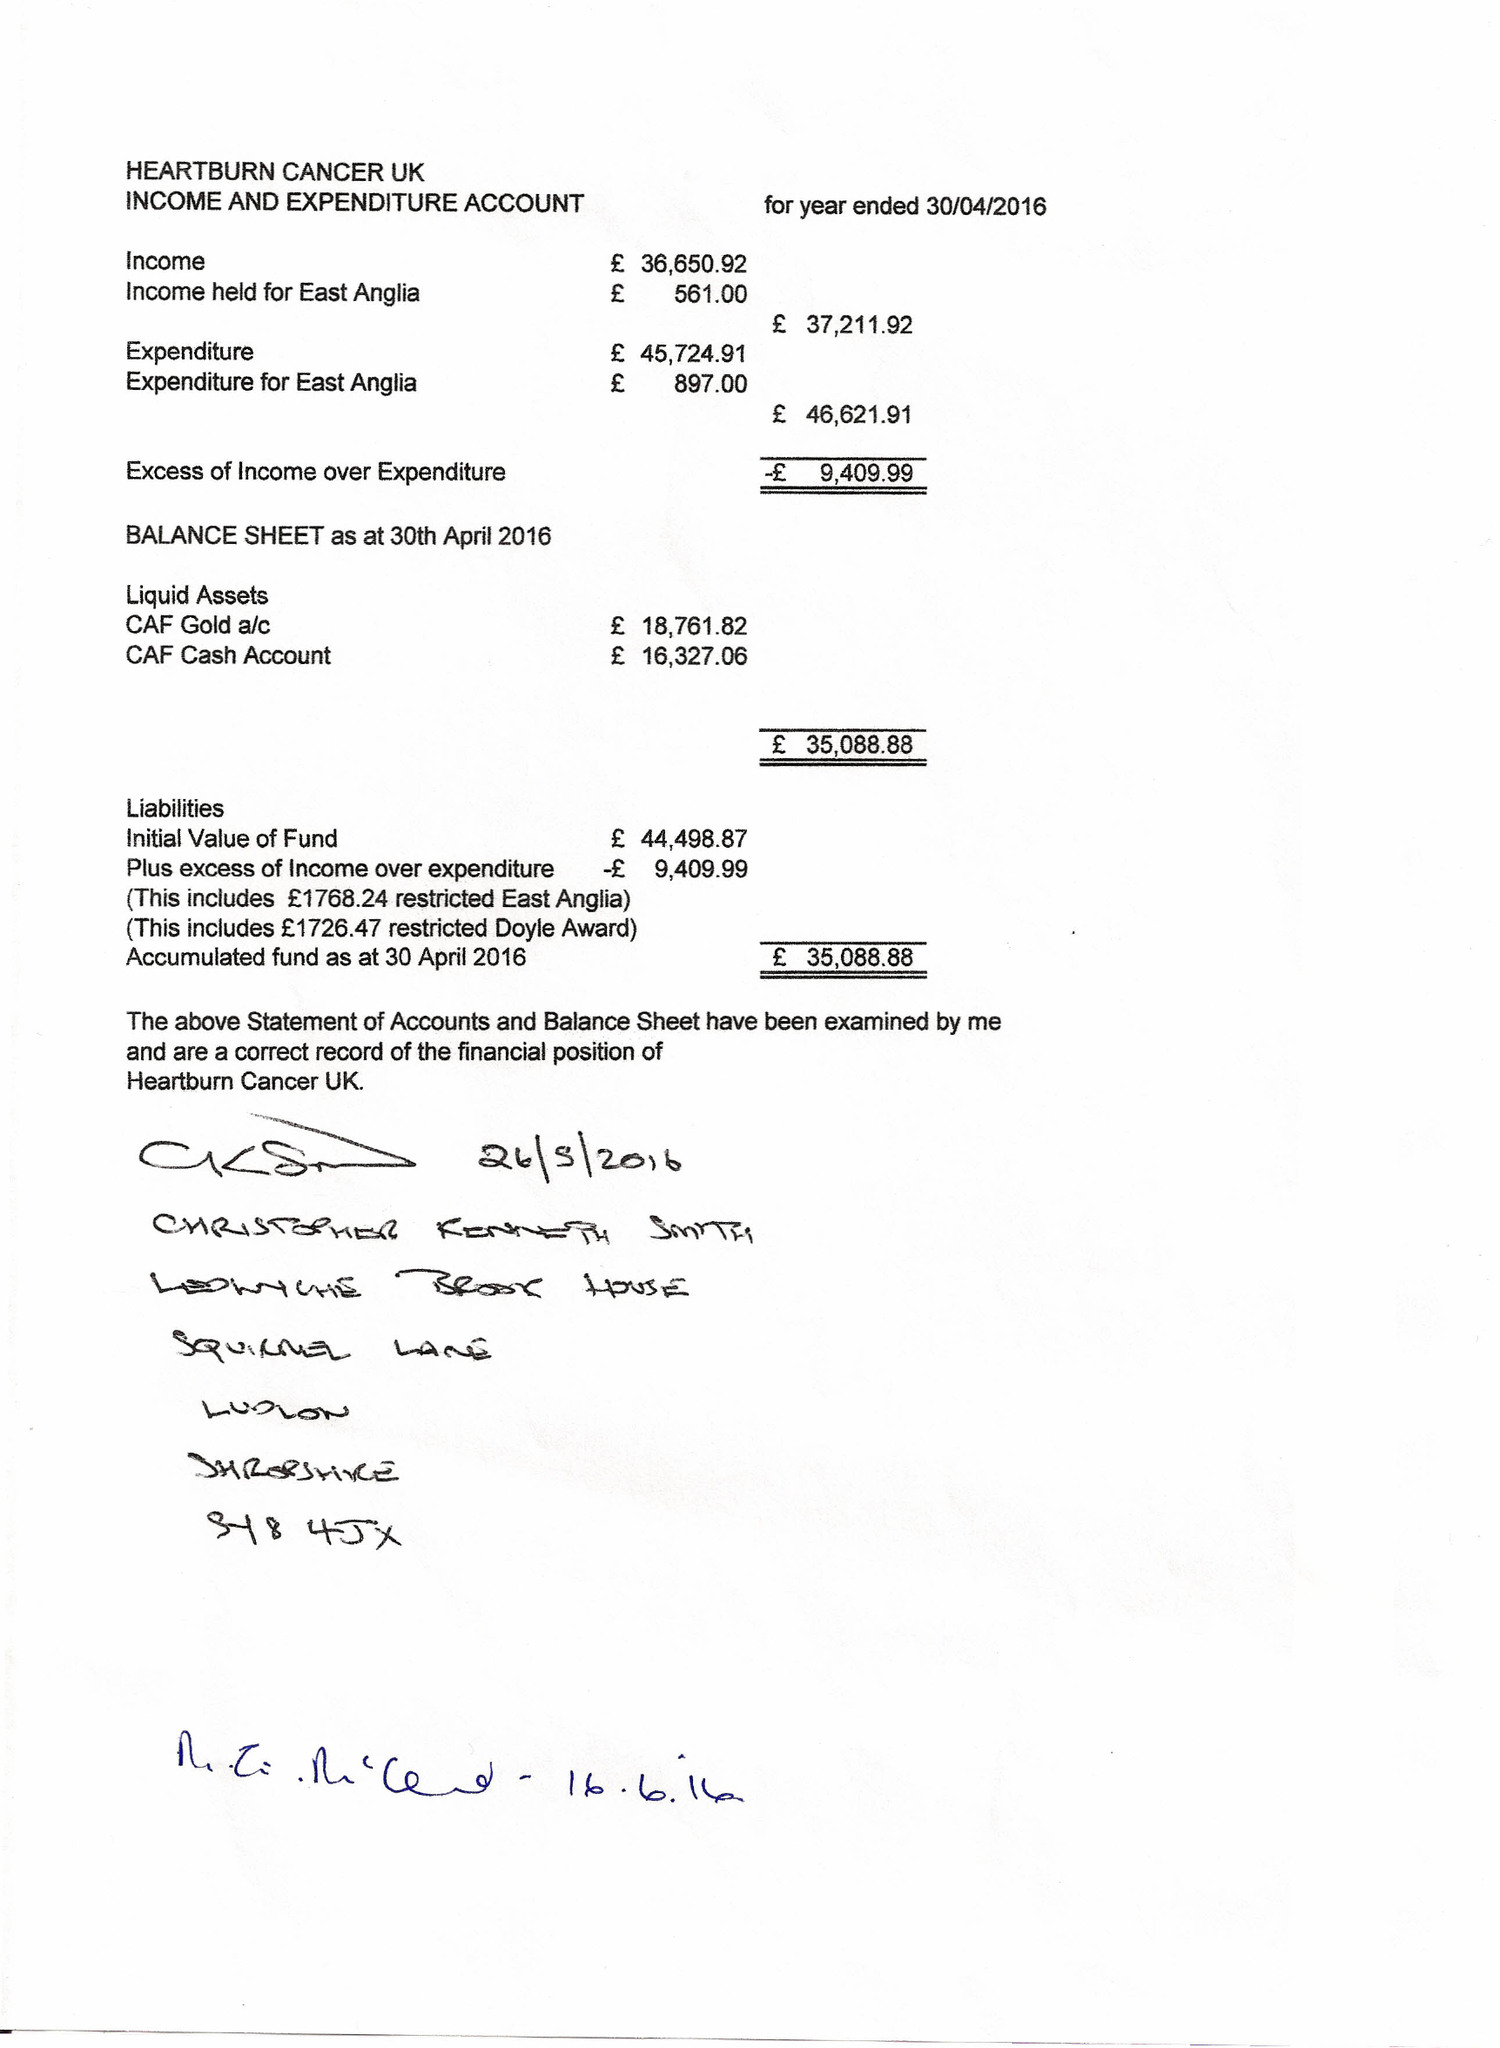What is the value for the charity_name?
Answer the question using a single word or phrase. Heartburn Cancer Uk 